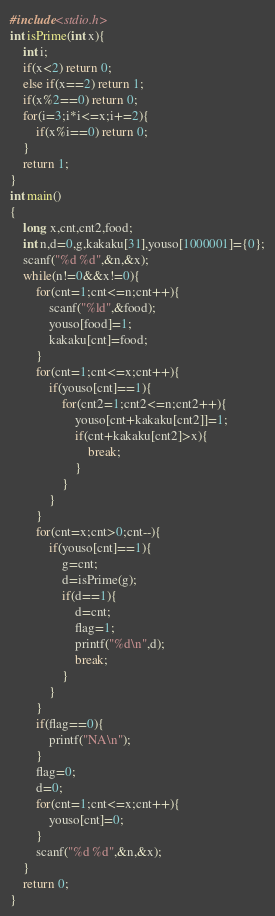Convert code to text. <code><loc_0><loc_0><loc_500><loc_500><_C++_>#include<stdio.h>
int isPrime(int x){
	int i;
	if(x<2) return 0;
	else if(x==2) return 1;
	if(x%2==0) return 0;
	for(i=3;i*i<=x;i+=2){
		if(x%i==0) return 0;
	}
	return 1;
}
int main()
{
	long x,cnt,cnt2,food;
	int n,d=0,g,kakaku[31],youso[1000001]={0};
	scanf("%d %d",&n,&x);
	while(n!=0&&x!=0){
		for(cnt=1;cnt<=n;cnt++){
			scanf("%ld",&food);
			youso[food]=1;
			kakaku[cnt]=food;
		}
		for(cnt=1;cnt<=x;cnt++){
			if(youso[cnt]==1){
				for(cnt2=1;cnt2<=n;cnt2++){
					youso[cnt+kakaku[cnt2]]=1;
					if(cnt+kakaku[cnt2]>x){
						break;
					}
				}
			}
		}
		for(cnt=x;cnt>0;cnt--){
			if(youso[cnt]==1){
				g=cnt;
				d=isPrime(g);
				if(d==1){
					d=cnt;
					flag=1;
					printf("%d\n",d);
					break;
				}
			}
		}
		if(flag==0){
			printf("NA\n");
		}
		flag=0;
		d=0;
		for(cnt=1;cnt<=x;cnt++){
			youso[cnt]=0;
		}
		scanf("%d %d",&n,&x);
	}
	return 0;
}</code> 